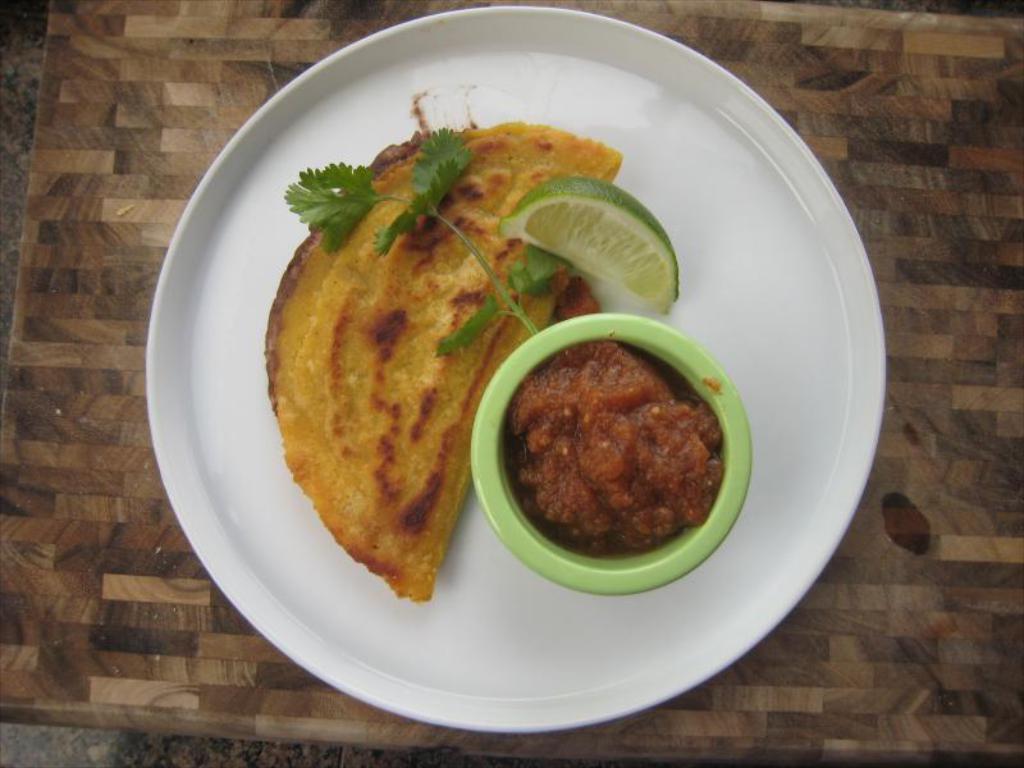Describe this image in one or two sentences. In this image, we can see a food item and a lemon along with sauce in the plate, which are placed on the table. 